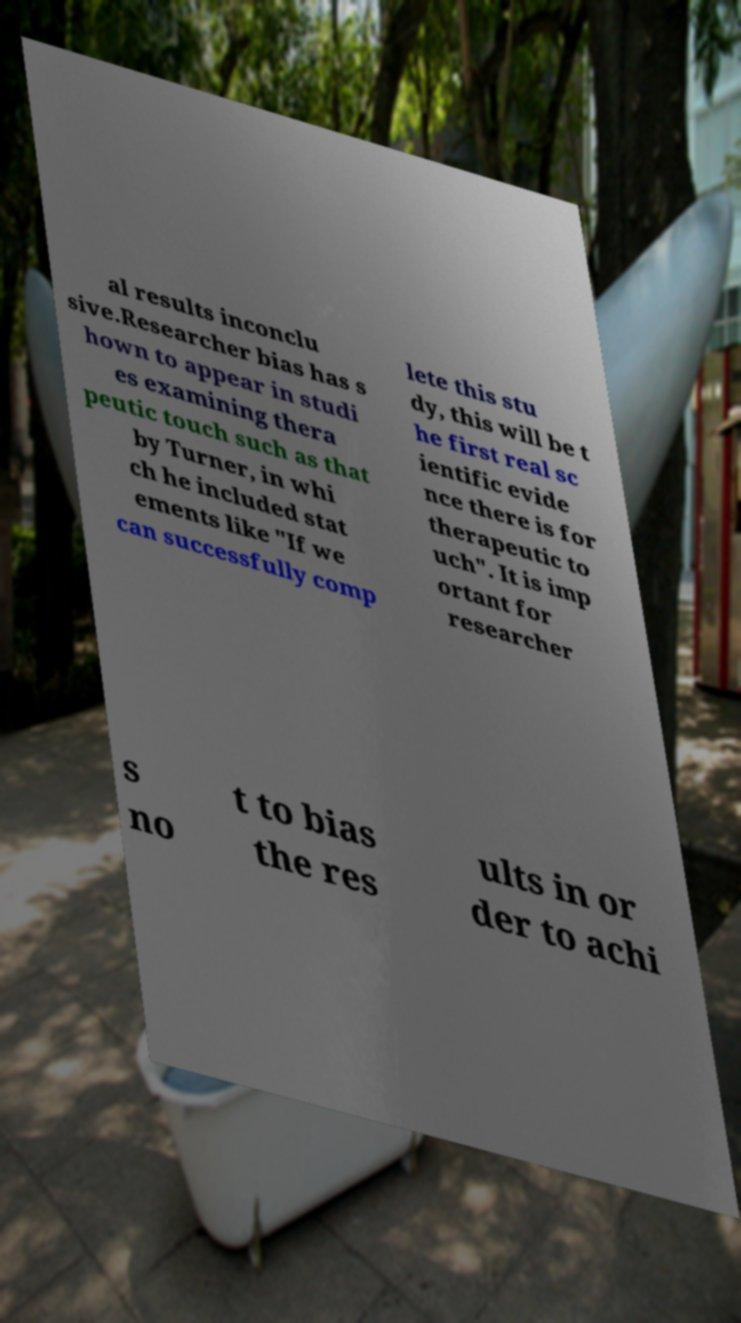Please identify and transcribe the text found in this image. al results inconclu sive.Researcher bias has s hown to appear in studi es examining thera peutic touch such as that by Turner, in whi ch he included stat ements like "If we can successfully comp lete this stu dy, this will be t he first real sc ientific evide nce there is for therapeutic to uch". It is imp ortant for researcher s no t to bias the res ults in or der to achi 